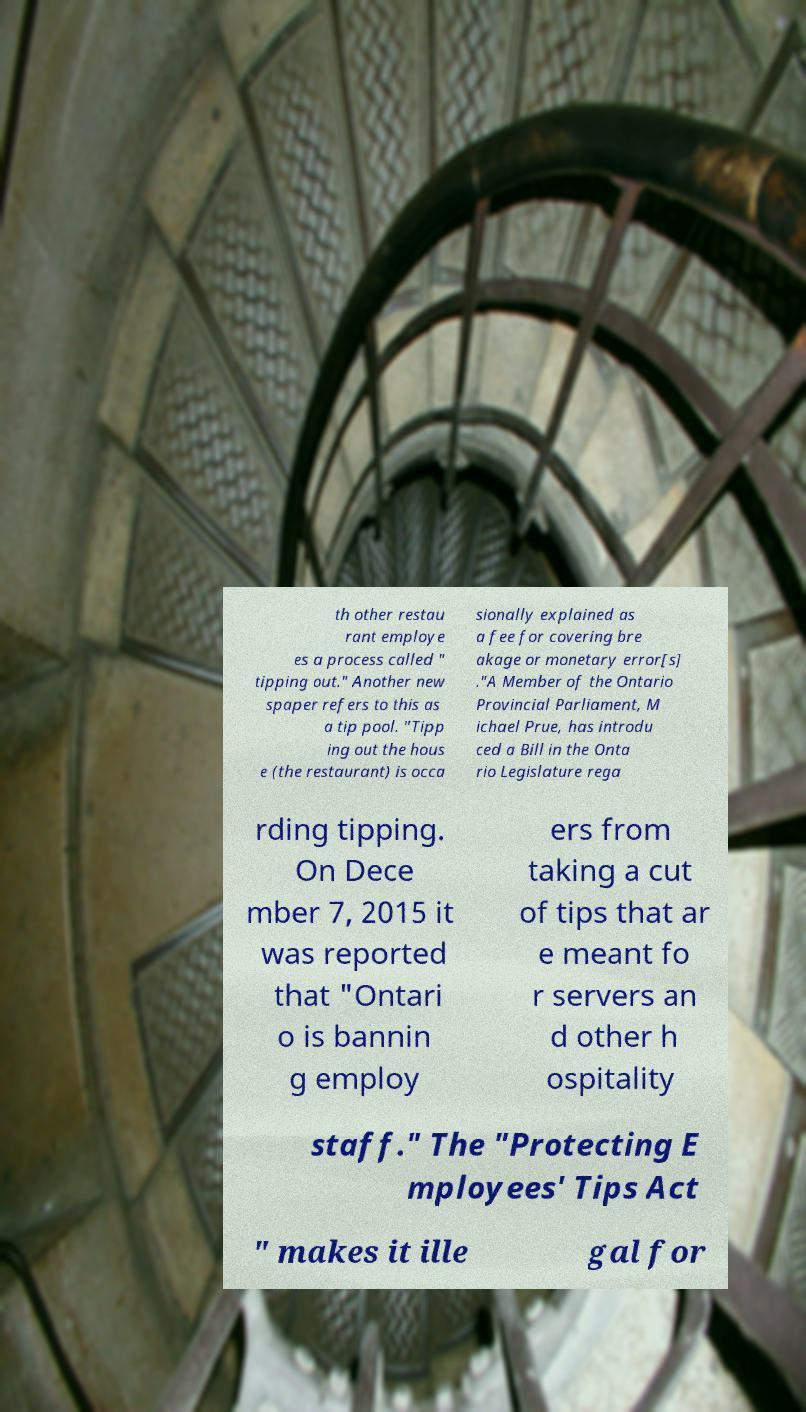Could you assist in decoding the text presented in this image and type it out clearly? th other restau rant employe es a process called " tipping out." Another new spaper refers to this as a tip pool. "Tipp ing out the hous e (the restaurant) is occa sionally explained as a fee for covering bre akage or monetary error[s] ."A Member of the Ontario Provincial Parliament, M ichael Prue, has introdu ced a Bill in the Onta rio Legislature rega rding tipping. On Dece mber 7, 2015 it was reported that "Ontari o is bannin g employ ers from taking a cut of tips that ar e meant fo r servers an d other h ospitality staff." The "Protecting E mployees' Tips Act " makes it ille gal for 